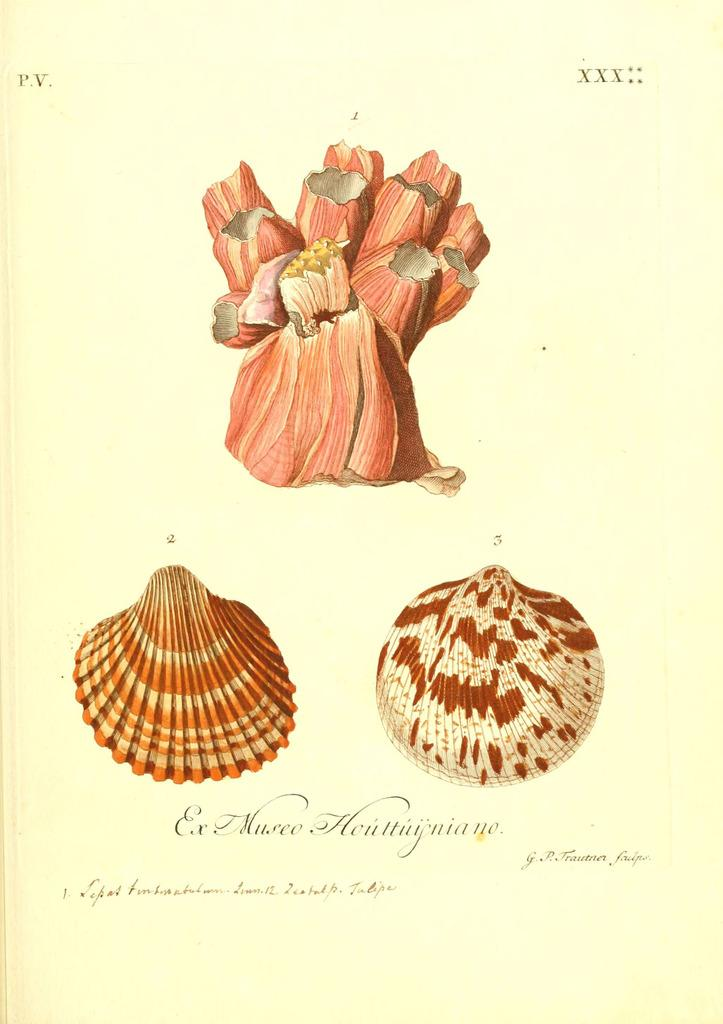What is the primary object in the image? The image contains a paper. What can be found on the paper? There are photos, words, and roman numerals on the paper. What type of feast is being prepared in the image? There is no indication of a feast or any food preparation in the image; it contains a paper with photos, words, and roman numerals. Can you describe the facial expressions of the people in the image? There are no people or faces present in the image; it contains a paper with photos, words, and roman numerals. 